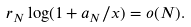Convert formula to latex. <formula><loc_0><loc_0><loc_500><loc_500>r _ { N } \log ( 1 + a _ { N } / x ) = o ( N ) .</formula> 